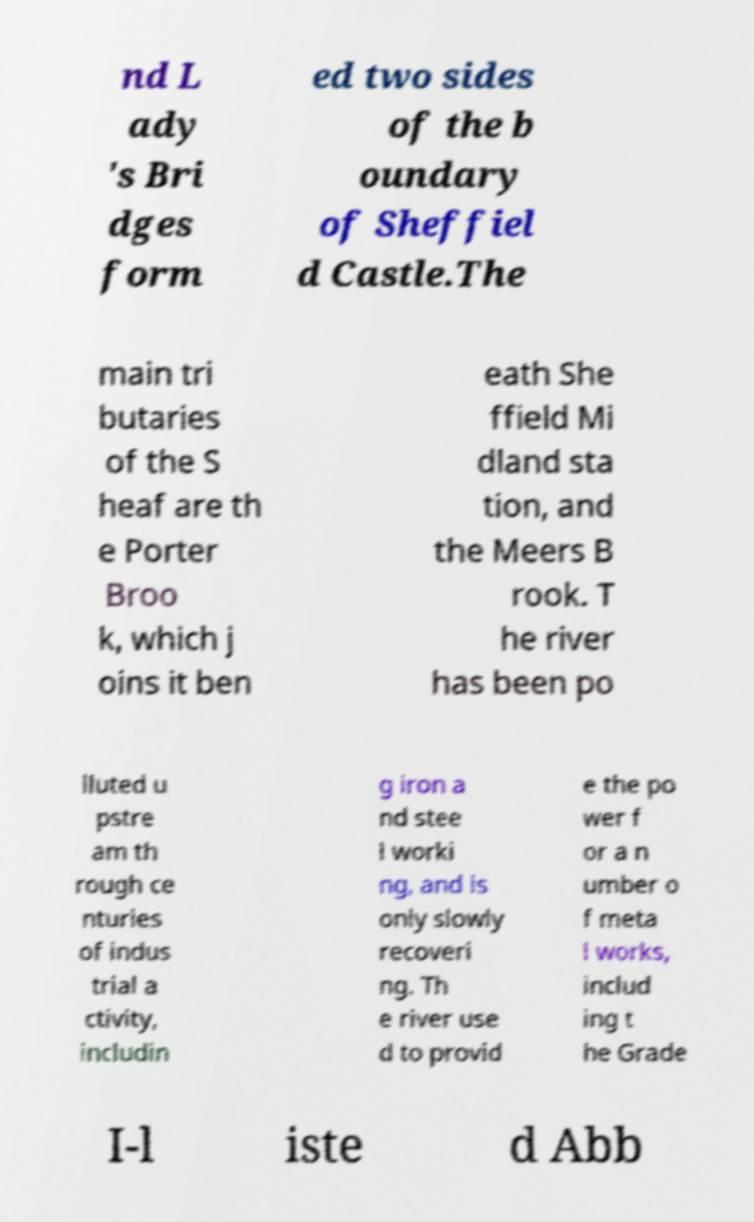What messages or text are displayed in this image? I need them in a readable, typed format. nd L ady 's Bri dges form ed two sides of the b oundary of Sheffiel d Castle.The main tri butaries of the S heaf are th e Porter Broo k, which j oins it ben eath She ffield Mi dland sta tion, and the Meers B rook. T he river has been po lluted u pstre am th rough ce nturies of indus trial a ctivity, includin g iron a nd stee l worki ng, and is only slowly recoveri ng. Th e river use d to provid e the po wer f or a n umber o f meta l works, includ ing t he Grade I-l iste d Abb 